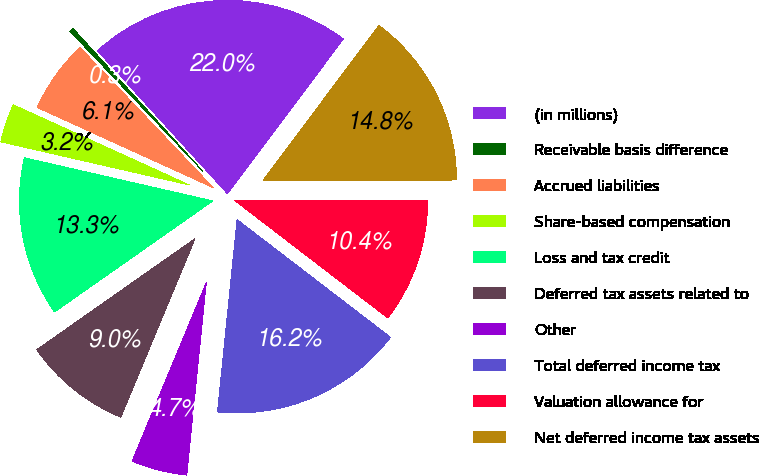<chart> <loc_0><loc_0><loc_500><loc_500><pie_chart><fcel>(in millions)<fcel>Receivable basis difference<fcel>Accrued liabilities<fcel>Share-based compensation<fcel>Loss and tax credit<fcel>Deferred tax assets related to<fcel>Other<fcel>Total deferred income tax<fcel>Valuation allowance for<fcel>Net deferred income tax assets<nl><fcel>21.97%<fcel>0.34%<fcel>6.11%<fcel>3.22%<fcel>13.32%<fcel>8.99%<fcel>4.66%<fcel>16.2%<fcel>10.43%<fcel>14.76%<nl></chart> 